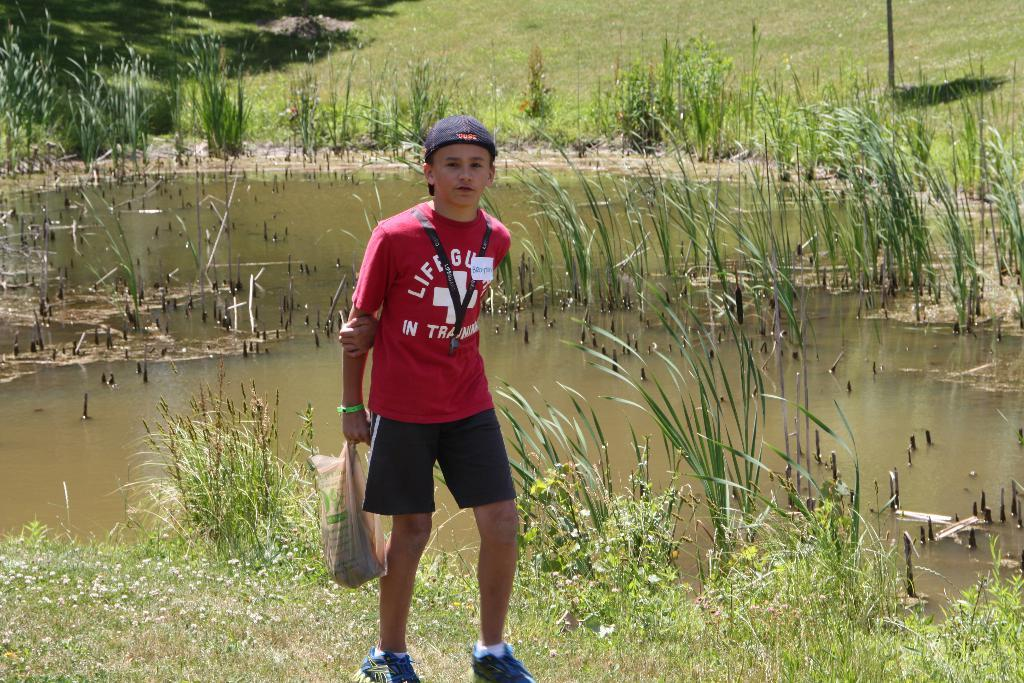Who is the main subject in the image? There is a boy in the image. What is the boy wearing? The boy is wearing black shorts. What is the boy holding in the image? The boy is holding a cover. Where is the boy standing? The boy is standing on the grass. What can be seen in the background of the image? There is water, plants, a tree, and grass visible in the background. What type of food is the boy eating in the image? There is no food visible in the image; the boy is holding a cover. How many cats are present in the image? There are no cats present in the image. 